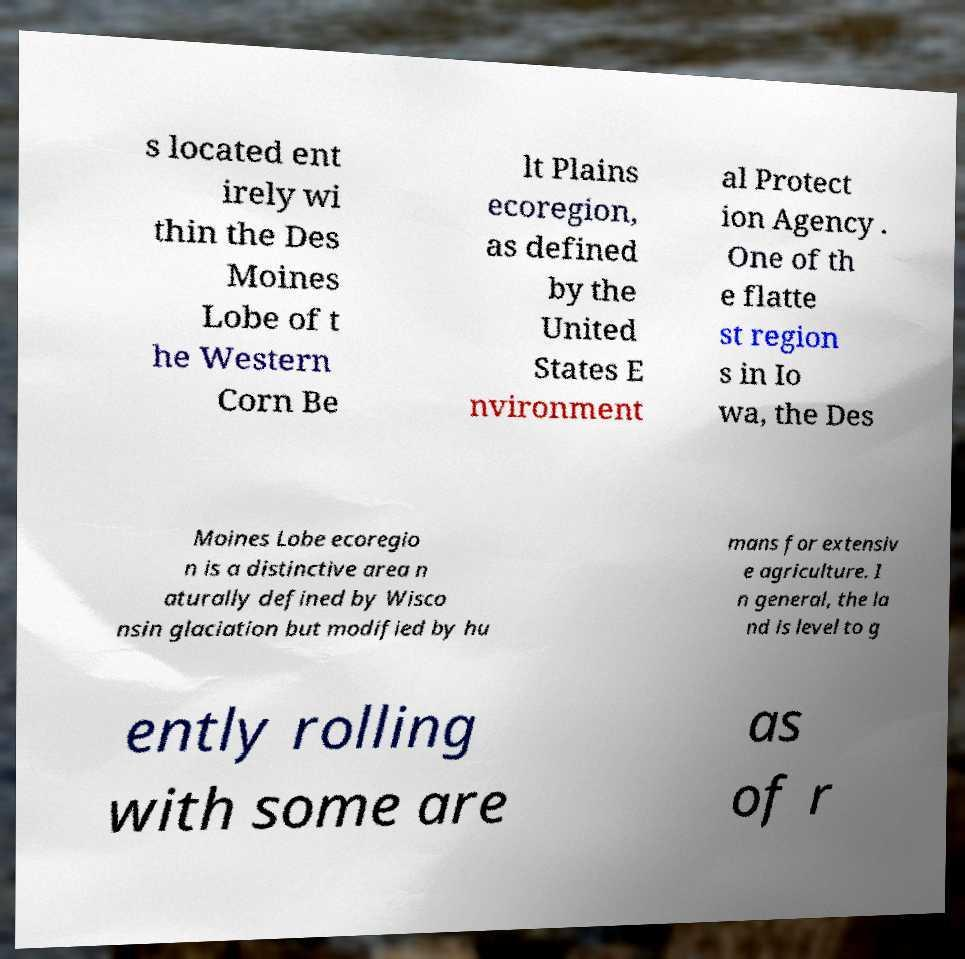Could you extract and type out the text from this image? s located ent irely wi thin the Des Moines Lobe of t he Western Corn Be lt Plains ecoregion, as defined by the United States E nvironment al Protect ion Agency . One of th e flatte st region s in Io wa, the Des Moines Lobe ecoregio n is a distinctive area n aturally defined by Wisco nsin glaciation but modified by hu mans for extensiv e agriculture. I n general, the la nd is level to g ently rolling with some are as of r 